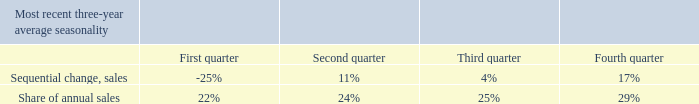Seasonality
The Company’s sales, income and cash flow from operations vary between quarters, and are generally lowest in the first quarter of the from operations vary between quarters, and are generally lowest in the first quarter of the year and highest in the fourth quarter. This is mainly a result of the seasonal purchase patterns of network operators.
Which quarter has lowest in sales, income and cash flow from operations? First quarter. What is the share of annual sales in third quarter? 25%. What is the share of annual sales in fourth quarter? 29%. What is the change in share of annual sales between first quarter and second quarter?
Answer scale should be: percent. 24%-22%
Answer: 2. What is the total share of annual sales for the second half of the year?
Answer scale should be: percent. 25%+29%
Answer: 54. What is the change in sequential change of sales between second and third quarter?
Answer scale should be: percent. 11-4
Answer: 7. 